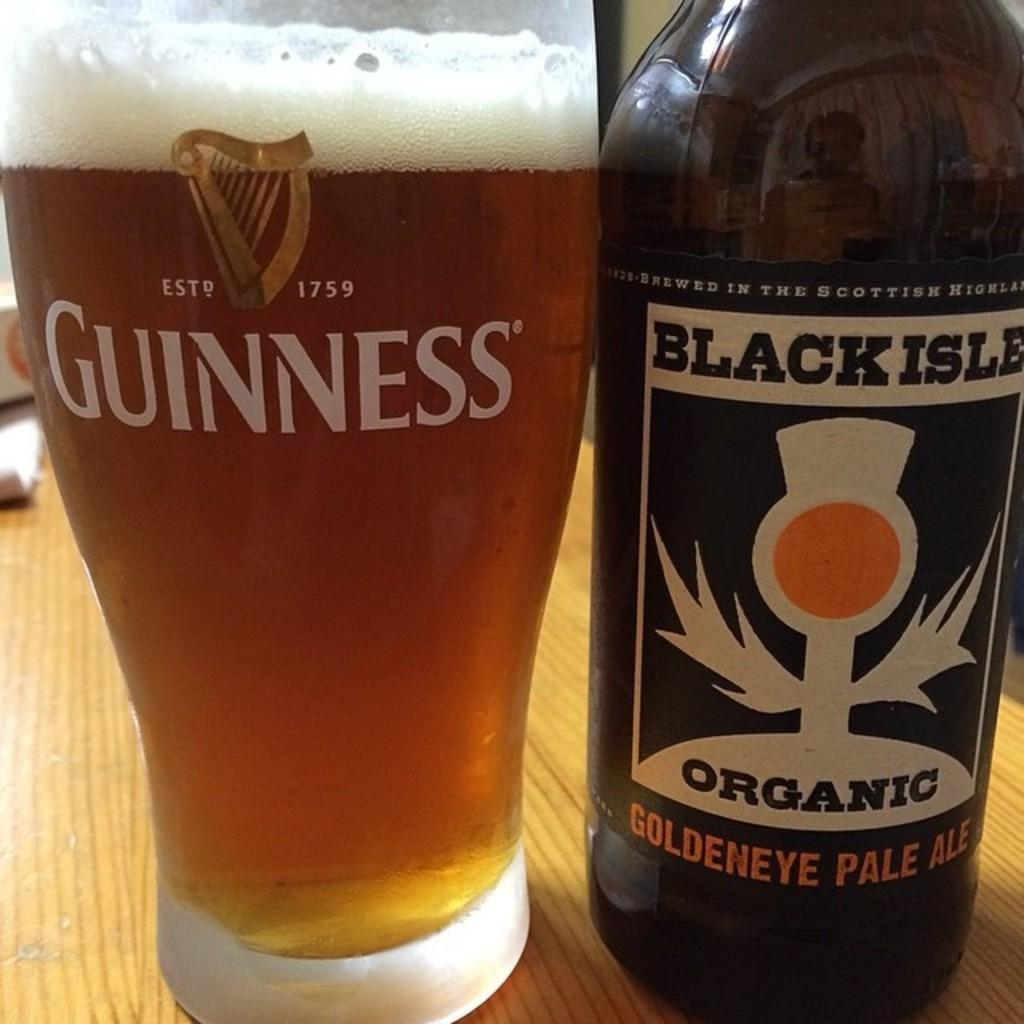<image>
Describe the image concisely. A pint of beer next to Black Aisle Pale Ale 